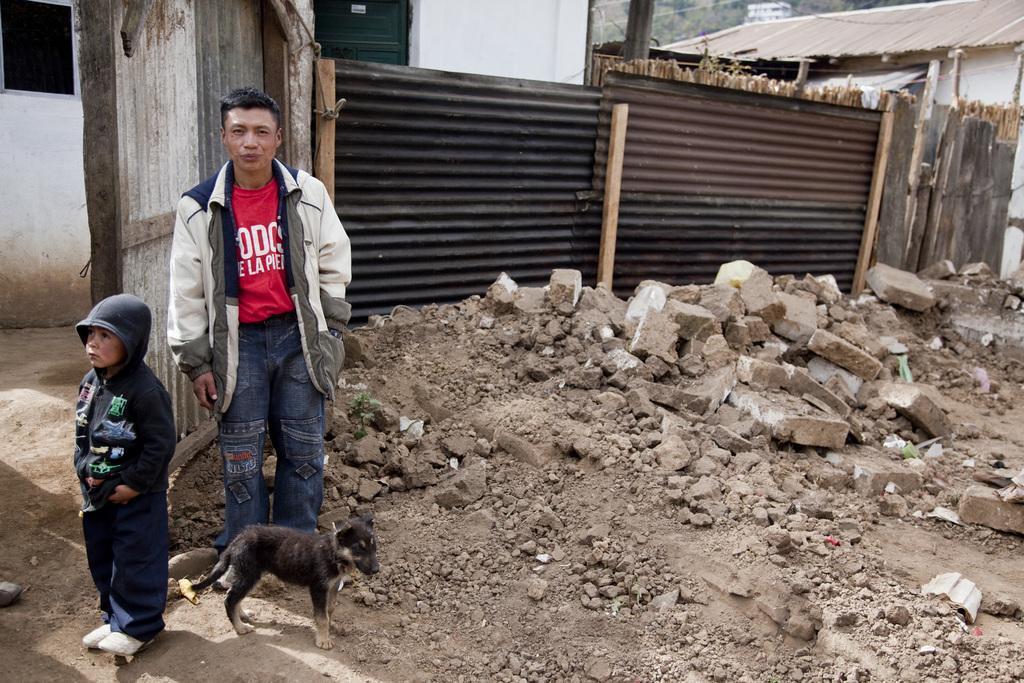Can you describe this image briefly? On the left side of the image we can see man and kid standing on the ground. At the bottom of the bottom of the image we can see dog. In the center of the image we can see stones. In the background we can see fencing, houses and trees. 